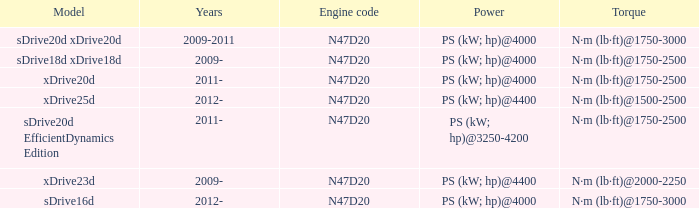What is the engine code of the xdrive23d model? N47D20. 